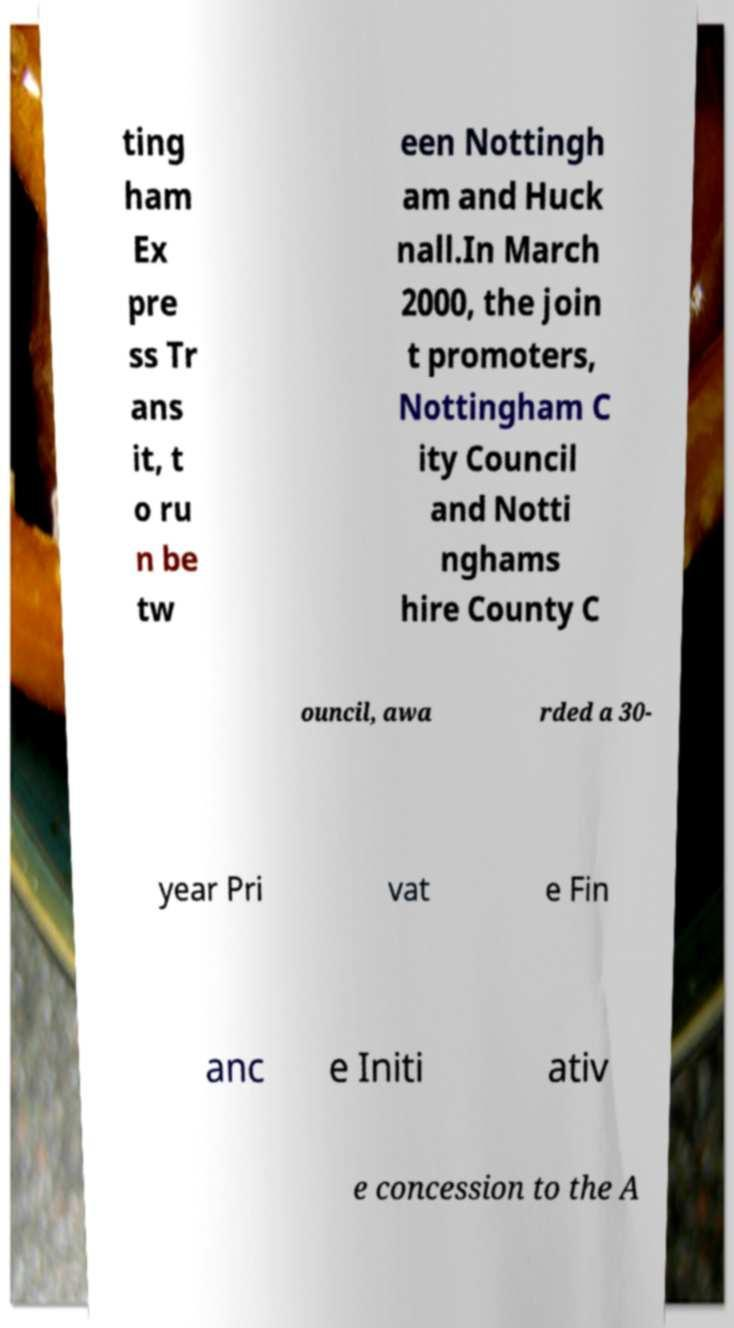Can you accurately transcribe the text from the provided image for me? ting ham Ex pre ss Tr ans it, t o ru n be tw een Nottingh am and Huck nall.In March 2000, the join t promoters, Nottingham C ity Council and Notti nghams hire County C ouncil, awa rded a 30- year Pri vat e Fin anc e Initi ativ e concession to the A 